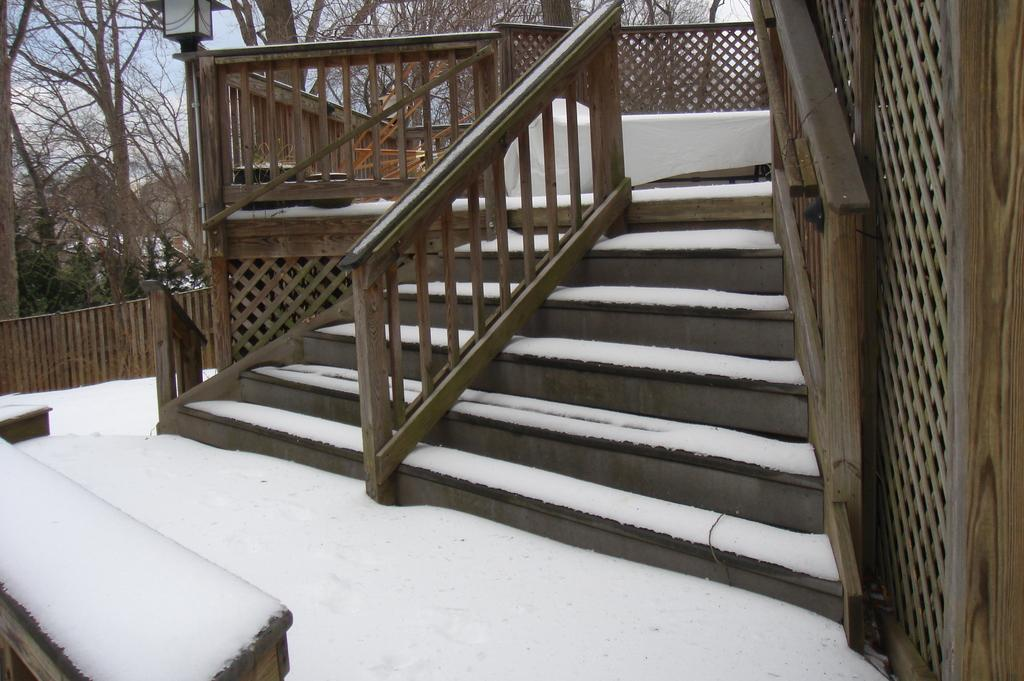What type of structure can be seen in the image? There is a house in the image. What is the terrain like in the image? There are steps and a fence visible in the image, and there is snow on the ground. What can be seen in the background of the image? There are trees, a light pole, and the sky visible in the background of the image. Can you describe the weather conditions in the image? The presence of snow suggests cold weather, and the image was likely taken during the day. What type of trees are being ploughed in the image? There are no trees being ploughed in the image, nor is there any indication of a plough or any agricultural activity. Can you locate the map in the image? There is no map present in the image. 